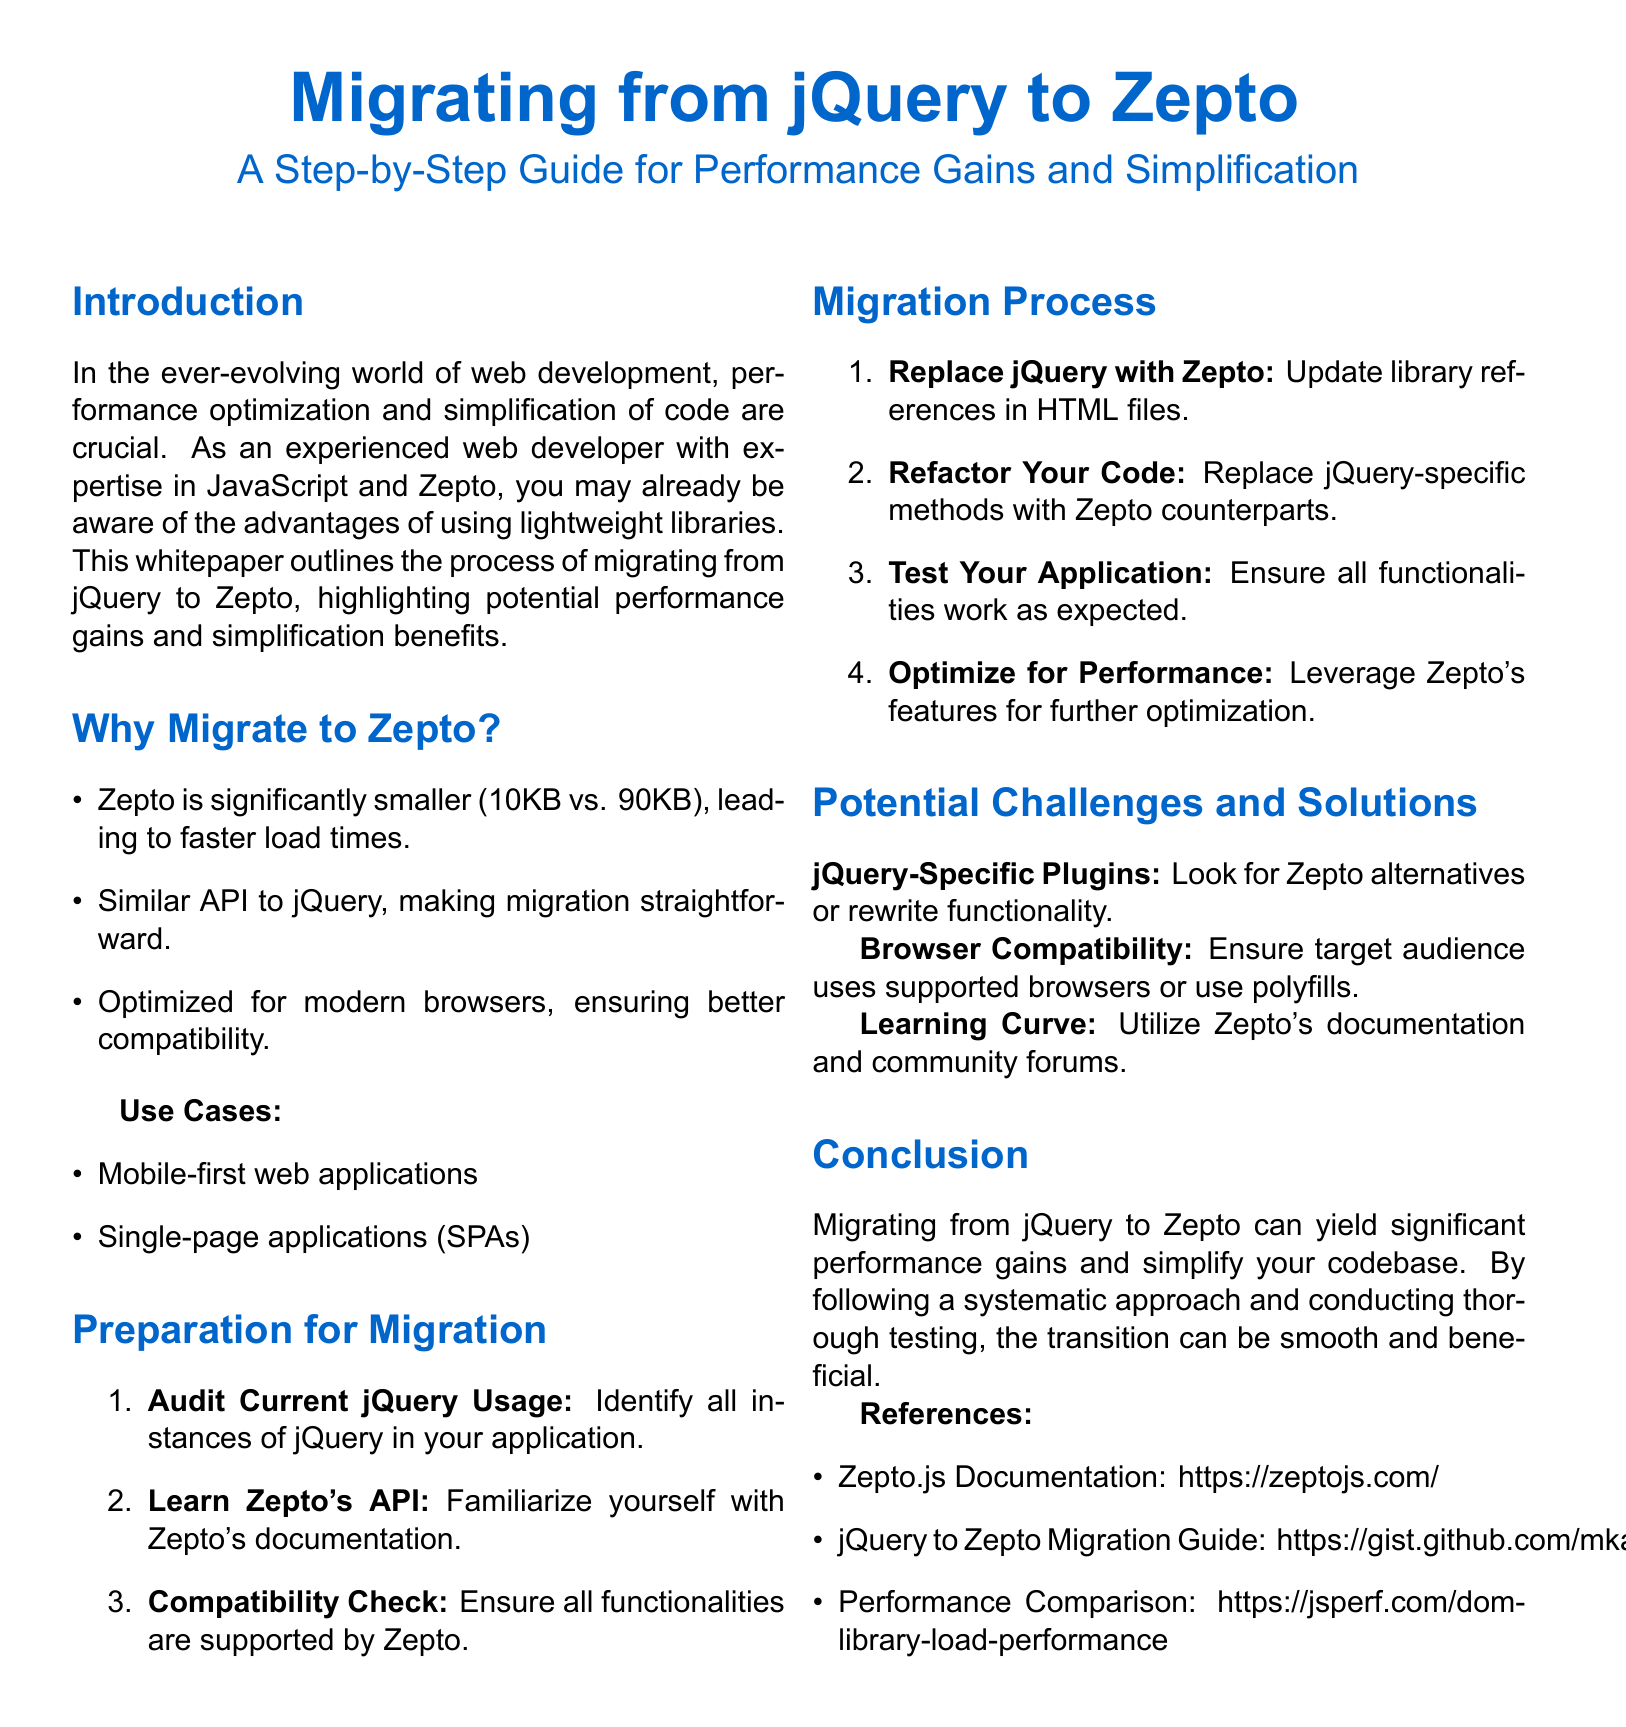What is the file size difference between Zepto and jQuery? The file size difference is highlighted in the document, where Zepto is 10KB and jQuery is 90KB.
Answer: 80KB What is one use case for migrating to Zepto? A use case is provided in the document, which includes mobile-first web applications.
Answer: Mobile-first web applications What is the first step in the migration preparation? The document outlines the steps, with the first being to audit current jQuery usage.
Answer: Audit Current jQuery Usage Which method should be replaced during the migration process? The document specifies that jQuery-specific methods should be replaced with their Zepto counterparts.
Answer: jQuery-specific methods What does Zepto optimize for? The focus of Zepto is explained in the document, emphasizing optimization for modern browsers.
Answer: Modern browsers What challenge may arise with jQuery-specific plugins? The document mentions the challenge of finding Zepto alternatives or rewriting functionality.
Answer: jQuery-Specific Plugins How many main sections are there in the document? The document can be analyzed, and it has six main sections listed.
Answer: Six What is a resource provided for further reading on Zepto? The document lists references, highlighting the Zepto.js Documentation as a resource.
Answer: Zepto.js Documentation What is the suggested action related to performance optimization in the migration process? The document instructs to leverage Zepto's features for further optimization.
Answer: Optimize for Performance 